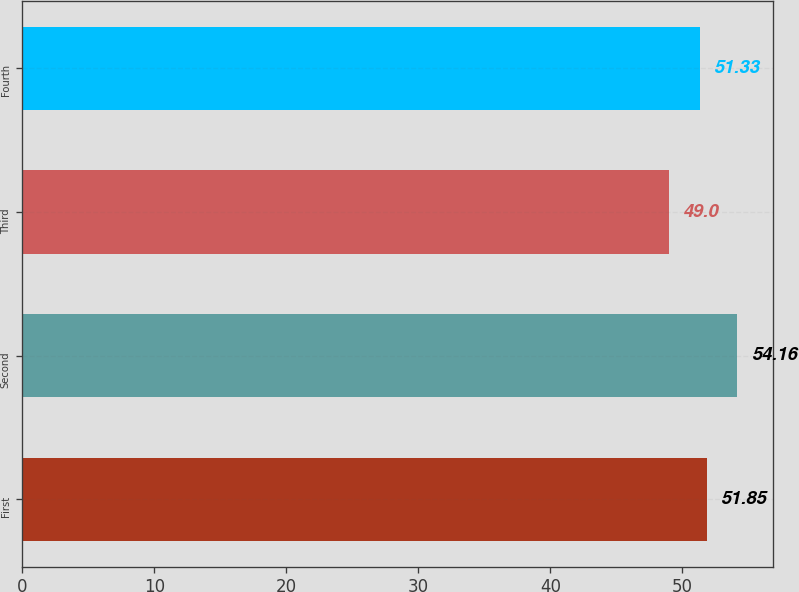Convert chart to OTSL. <chart><loc_0><loc_0><loc_500><loc_500><bar_chart><fcel>First<fcel>Second<fcel>Third<fcel>Fourth<nl><fcel>51.85<fcel>54.16<fcel>49<fcel>51.33<nl></chart> 